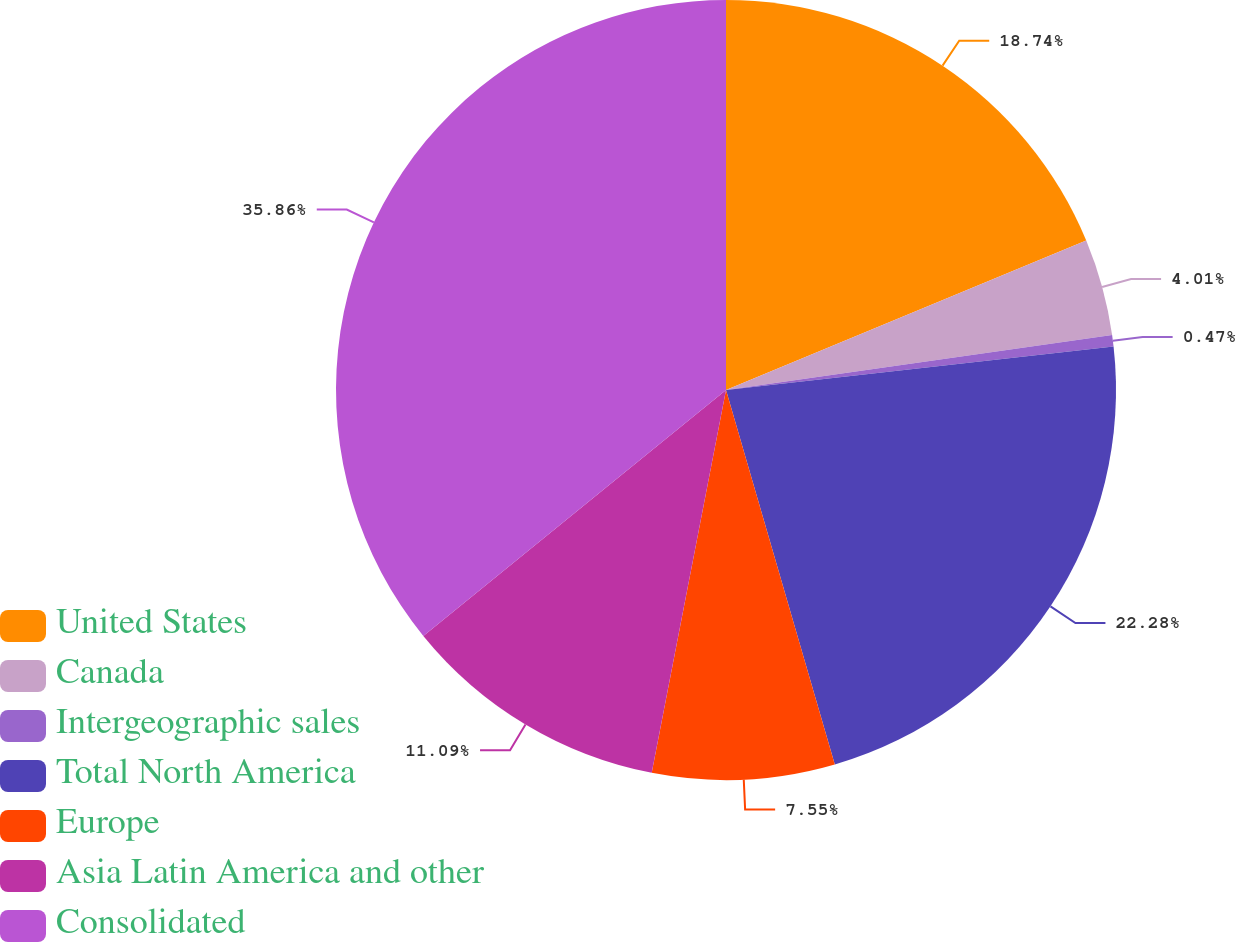Convert chart to OTSL. <chart><loc_0><loc_0><loc_500><loc_500><pie_chart><fcel>United States<fcel>Canada<fcel>Intergeographic sales<fcel>Total North America<fcel>Europe<fcel>Asia Latin America and other<fcel>Consolidated<nl><fcel>18.74%<fcel>4.01%<fcel>0.47%<fcel>22.28%<fcel>7.55%<fcel>11.09%<fcel>35.86%<nl></chart> 